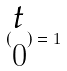Convert formula to latex. <formula><loc_0><loc_0><loc_500><loc_500>( \begin{matrix} t \\ 0 \end{matrix} ) = 1</formula> 